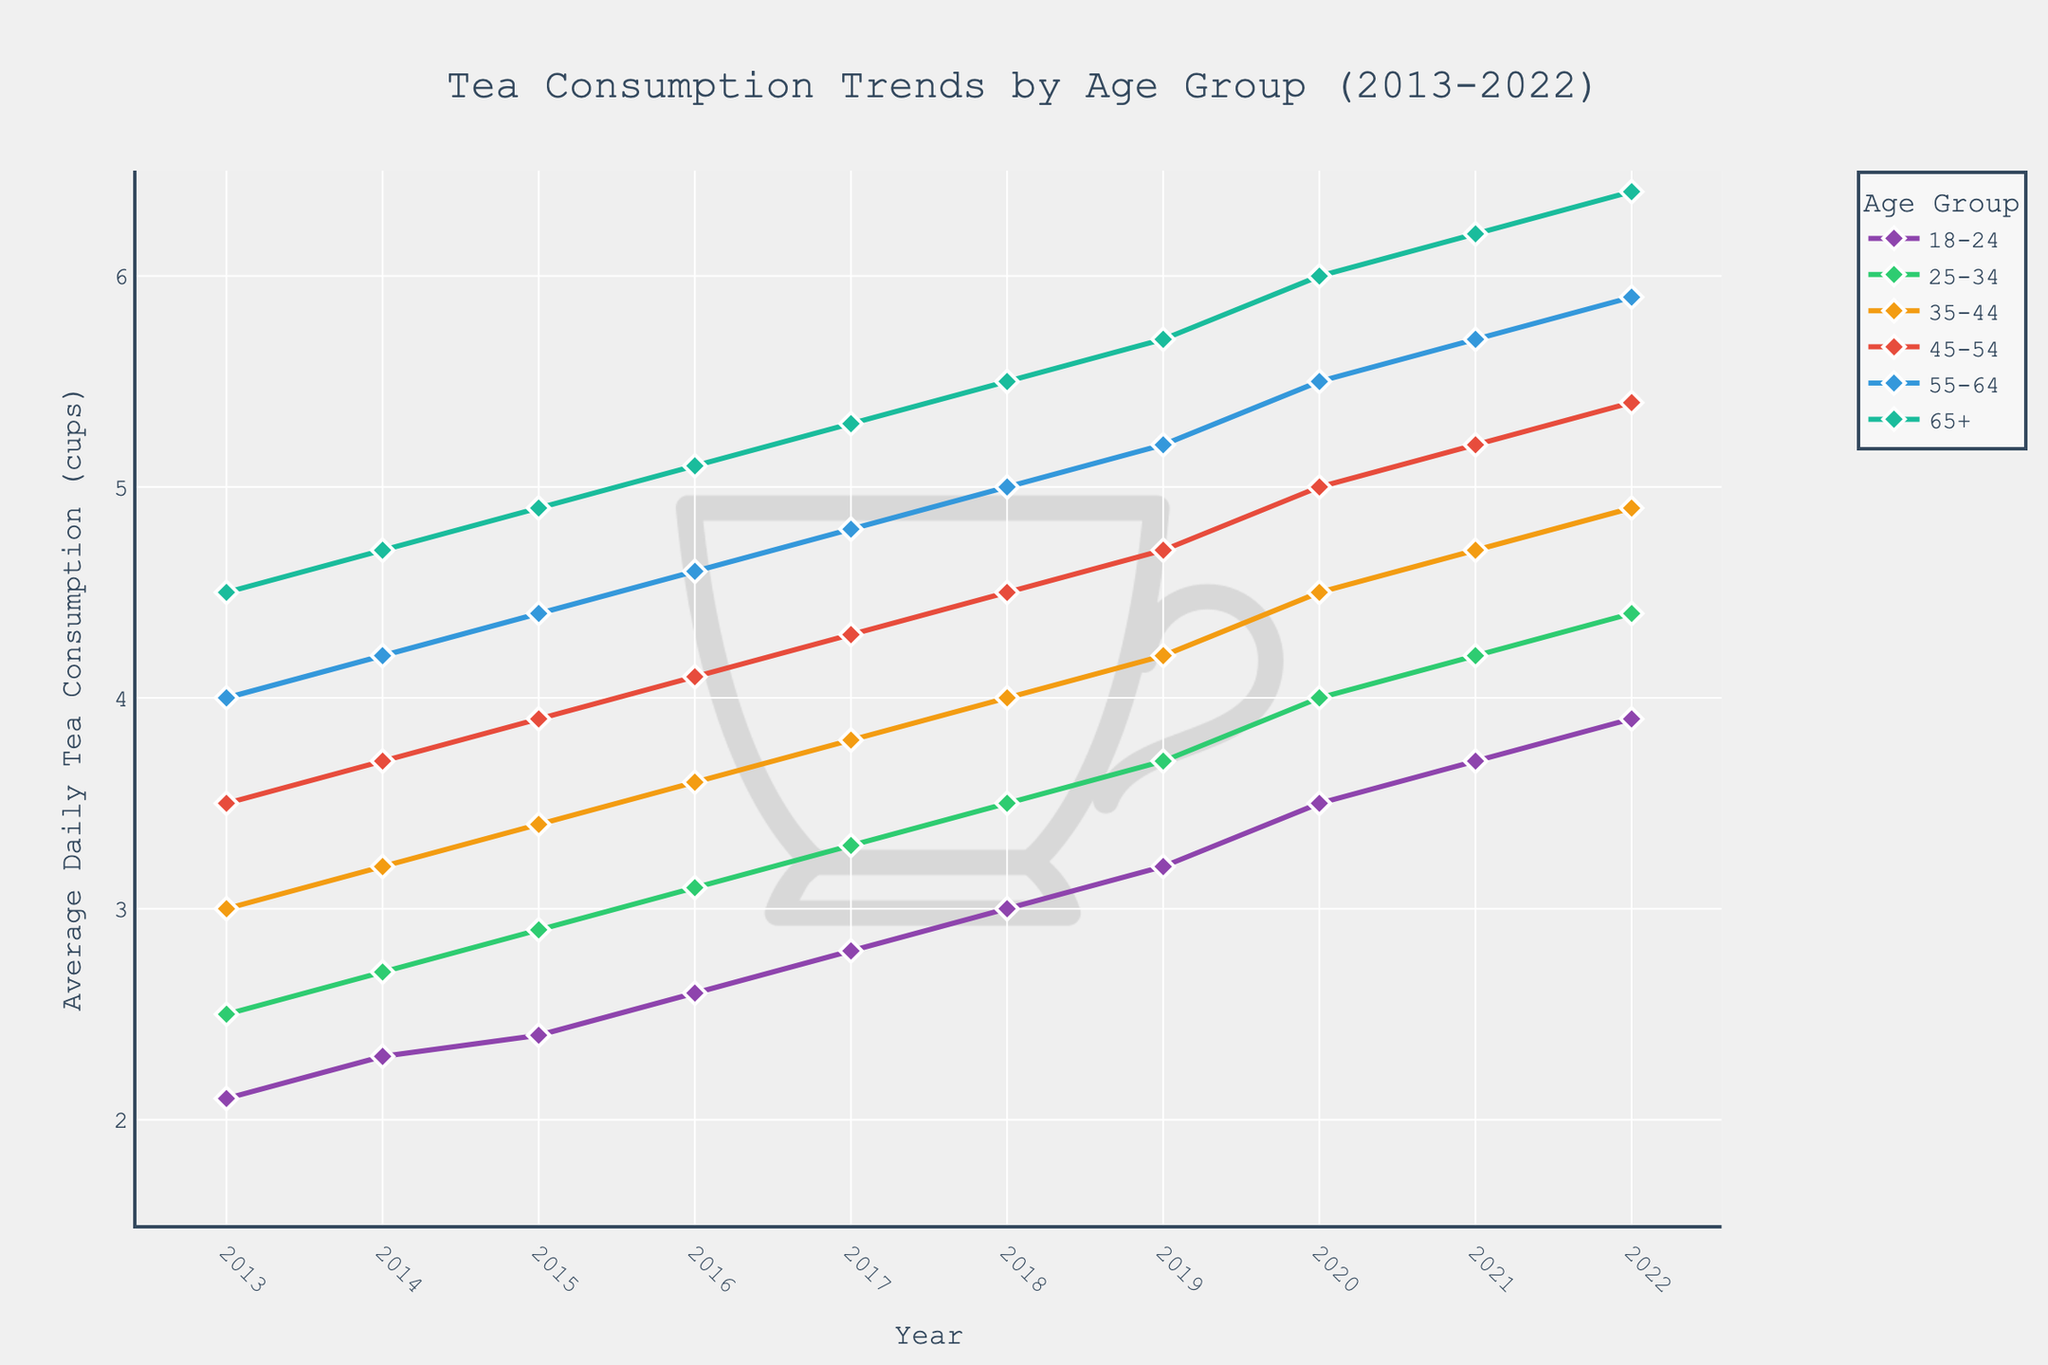What is the average daily tea consumption for the 18-24 age group in 2022? Look at the y-axis to find the value corresponding to the 18-24 age group in 2022.
Answer: 3.9 cups Which age group has the highest tea consumption throughout the decade? Observe the lines and their heights across the decade. The age group with the highest values on the y-axis consistently is the 65+ group.
Answer: 65+ How much did tea consumption increase for the 25-34 age group from 2013 to 2022? Subtract the initial value in 2013 from the final value in 2022 for the 25-34 age group. This is 4.4 - 2.5.
Answer: 1.9 cups Compare the tea consumption trends between the 35-44 and 55-64 age groups in 2018. Which group consumed more tea? Look at the line representing the 35-44 age group and compare its value in 2018 to that of the 55-64 age group.
Answer: 55-64 age group Which age group's tea consumption trend shows the steepest increase from 2016 to 2020? Identify which line has the steepest slope between 2016 and 2020. The steepest increase is shown by the 18-24 age group.
Answer: 18-24 What is the difference in tea consumption between the 45-54 age group and the 65+ age group in 2017? Subtract the consumption value of the 45-54 group from that of the 65+ group in 2017. 5.3 - 4.3.
Answer: 1 cup Which age group showed the largest increase in tea consumption from 2013 to 2018? Calculate the difference for each age group from 2013 to 2018, then compare them. The largest increase is shown by the 18-24 age group (3.0 - 2.1 = 0.9).
Answer: 18-24 What's the average tea consumption for all age groups in 2016? Add the consumption values of all age groups for 2016 and divide by the number of groups. (2.6 + 3.1 + 3.6 + 4.1 + 4.6 + 5.1) / 6.
Answer: 3.52 cups Between 2019 and 2022, did any age group's tea consumption remain constant? Check the plotted lines for each age group from 2019 to 2022 to see if any line is horizontal.
Answer: No 